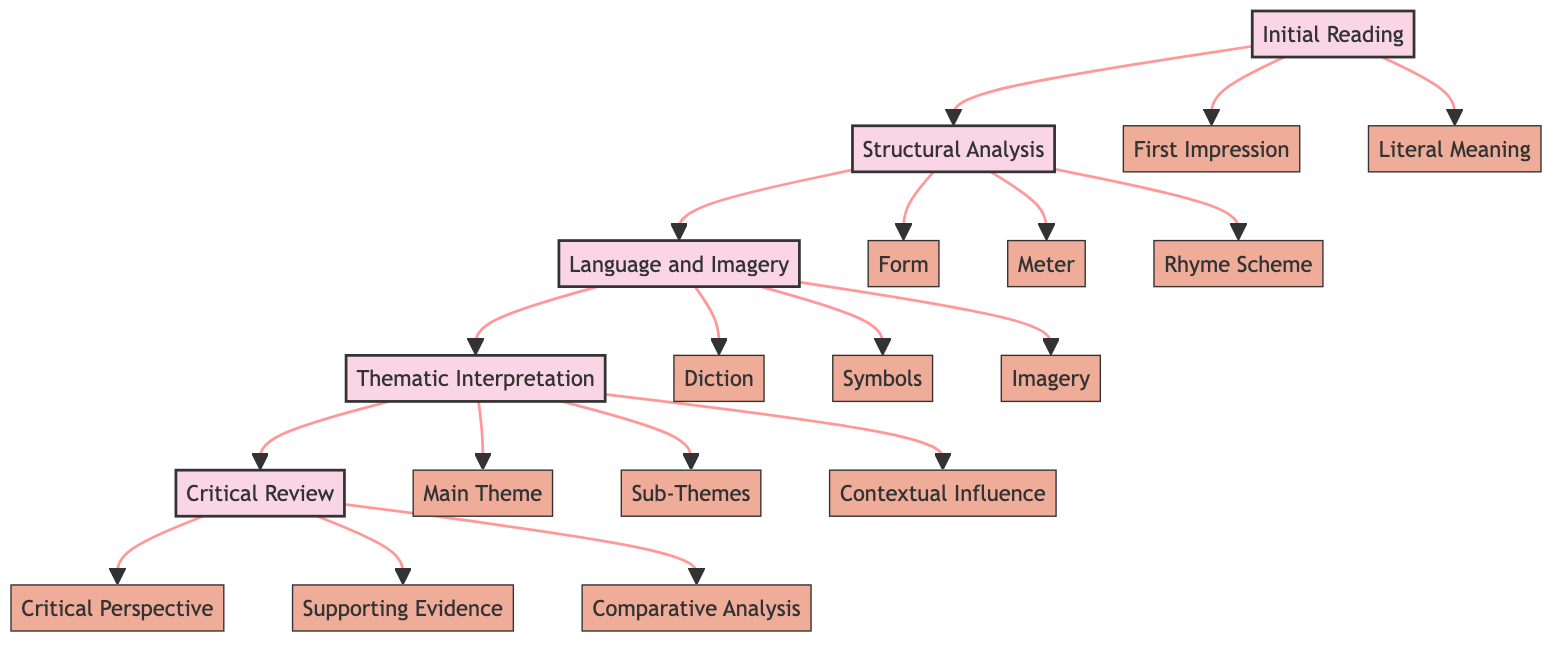What is the first step in the poem analysis process? According to the flowchart, the first step in analyzing a poem is "Initial Reading".
Answer: Initial Reading How many substeps are listed under "Structural Analysis"? The flowchart shows three substeps listed under "Structural Analysis": Form, Meter, and Rhyme Scheme.
Answer: 3 What follows "Language and Imagery"? In the flowchart, the step that follows "Language and Imagery" is "Thematic Interpretation".
Answer: Thematic Interpretation Which substep involves identifying the overarching theme? The substep that involves identifying the overarching theme is called "Main Theme".
Answer: Main Theme What is the final step in the analysis process? The final step in the analysis process, as depicted in the flowchart, is "Critical Review".
Answer: Critical Review What type of analysis is done in the substep "Supporting Evidence"? The "Supporting Evidence" substep involves using specific examples from the poem to support one's analysis.
Answer: Using specific examples How many main steps are there in the overall analysis process? The flowchart indicates there are five main steps in the poem analysis process.
Answer: 5 What is the relationship between "Structural Analysis" and "Language and Imagery"? "Structural Analysis" is a step that leads directly to "Language and Imagery" in the flowchart.
Answer: Leads directly to What is the main focus of "Diction" in the analysis? The main focus of "Diction" is to analyze word choices and their connotations.
Answer: Analyze word choices Which substep follows the "Contextual Influence" in the thematic interpretation process? The substep that follows "Contextual Influence" is "Critical Review".
Answer: Critical Review 